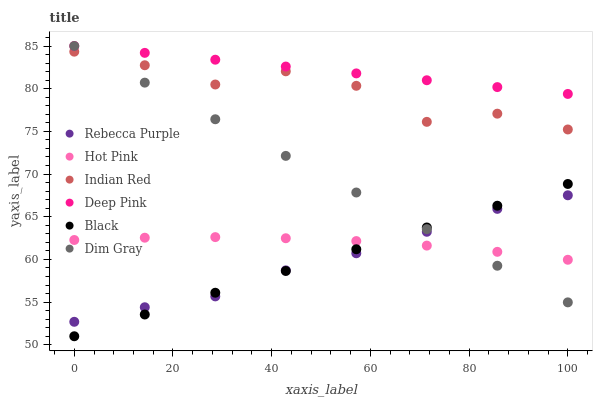Does Rebecca Purple have the minimum area under the curve?
Answer yes or no. Yes. Does Deep Pink have the maximum area under the curve?
Answer yes or no. Yes. Does Hot Pink have the minimum area under the curve?
Answer yes or no. No. Does Hot Pink have the maximum area under the curve?
Answer yes or no. No. Is Black the smoothest?
Answer yes or no. Yes. Is Indian Red the roughest?
Answer yes or no. Yes. Is Hot Pink the smoothest?
Answer yes or no. No. Is Hot Pink the roughest?
Answer yes or no. No. Does Black have the lowest value?
Answer yes or no. Yes. Does Hot Pink have the lowest value?
Answer yes or no. No. Does Deep Pink have the highest value?
Answer yes or no. Yes. Does Hot Pink have the highest value?
Answer yes or no. No. Is Rebecca Purple less than Deep Pink?
Answer yes or no. Yes. Is Deep Pink greater than Black?
Answer yes or no. Yes. Does Rebecca Purple intersect Hot Pink?
Answer yes or no. Yes. Is Rebecca Purple less than Hot Pink?
Answer yes or no. No. Is Rebecca Purple greater than Hot Pink?
Answer yes or no. No. Does Rebecca Purple intersect Deep Pink?
Answer yes or no. No. 